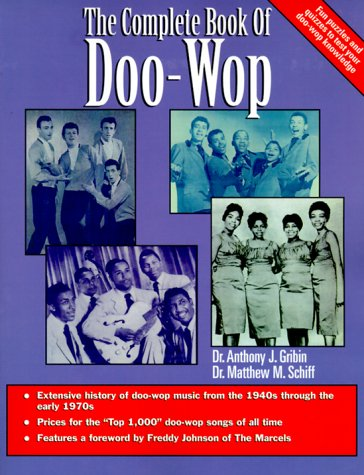What is the title of this book? This book is called 'The Complete Book of Doo-Wop Rhythm and Blues', reflecting its in-depth exploration of the Doo-Wop musical era from the 1940s to the early 1970s. 